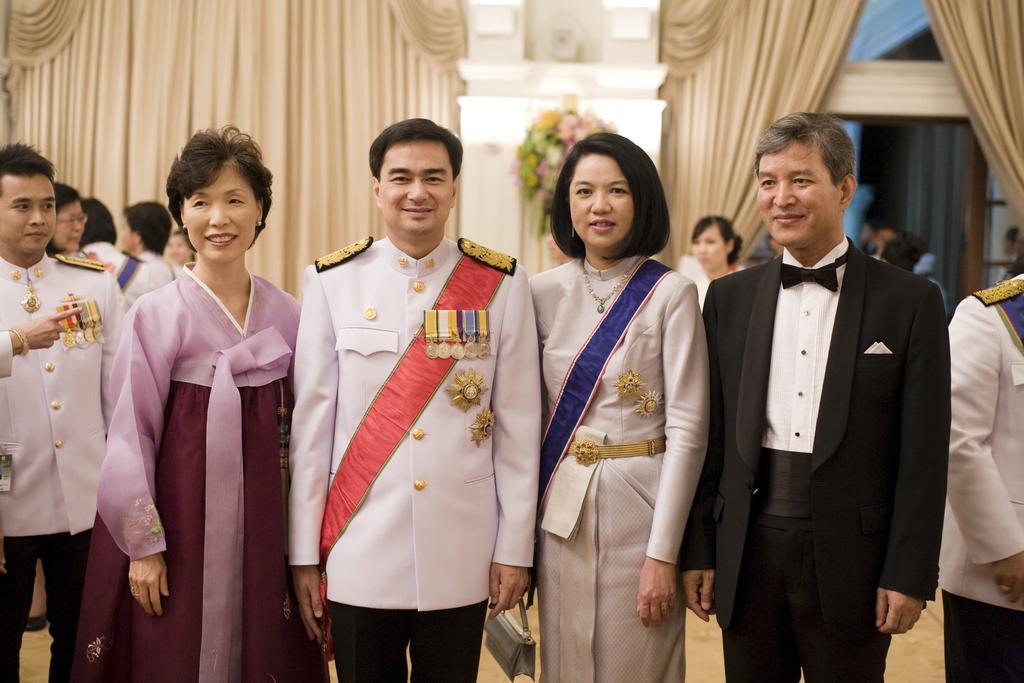In one or two sentences, can you explain what this image depicts? In the image in the center we can see few people were standing and they were smiling. In the background there is a wall,flower bouquet,curtains and few people were standing. 